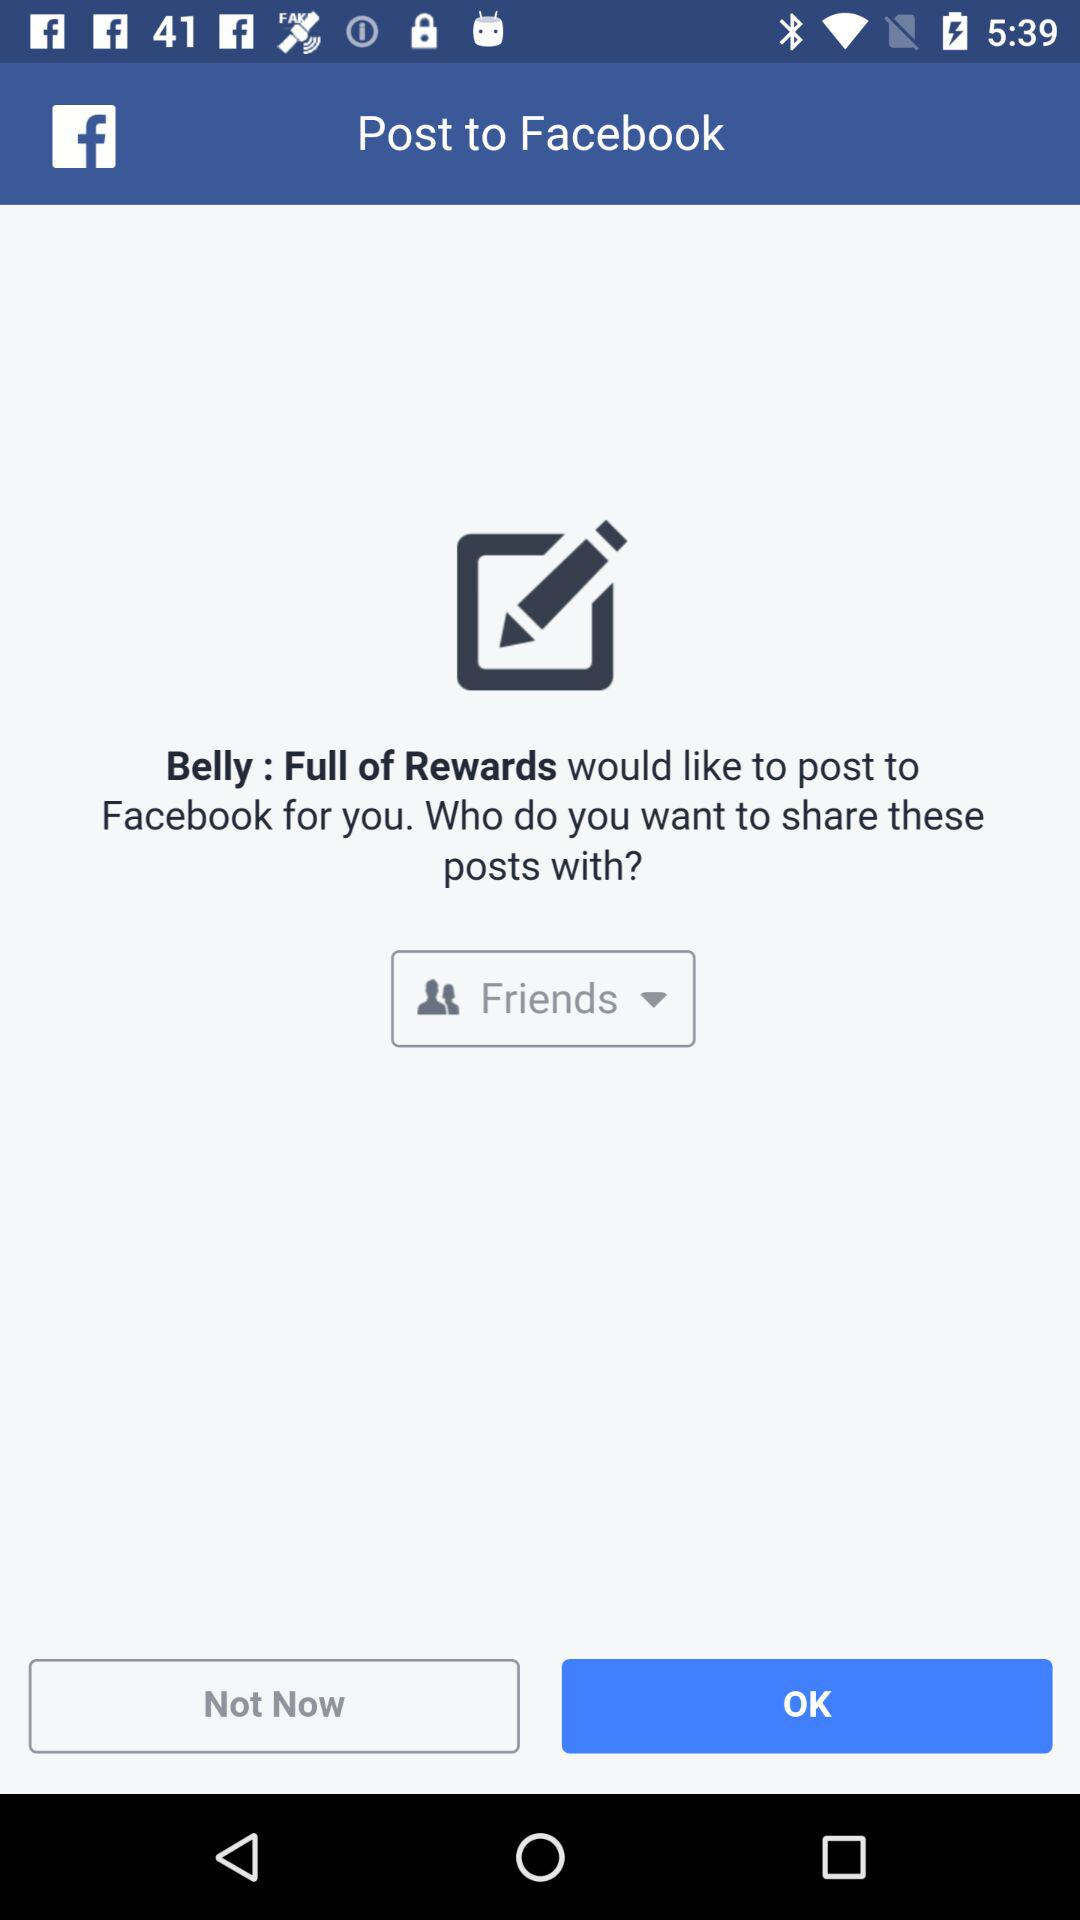With whom will these posts be shared? These posts will be shared with friends. 